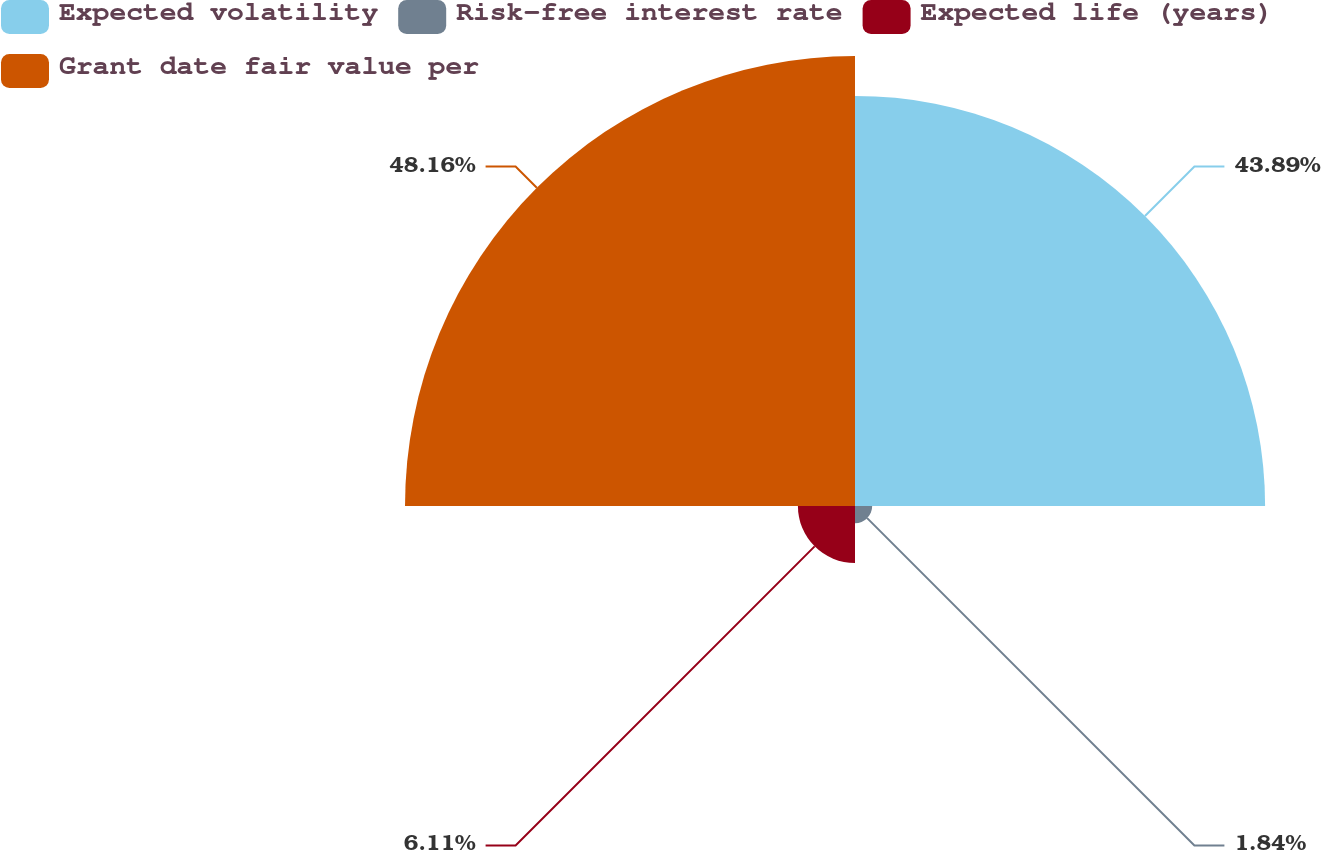Convert chart. <chart><loc_0><loc_0><loc_500><loc_500><pie_chart><fcel>Expected volatility<fcel>Risk-free interest rate<fcel>Expected life (years)<fcel>Grant date fair value per<nl><fcel>43.89%<fcel>1.84%<fcel>6.11%<fcel>48.16%<nl></chart> 